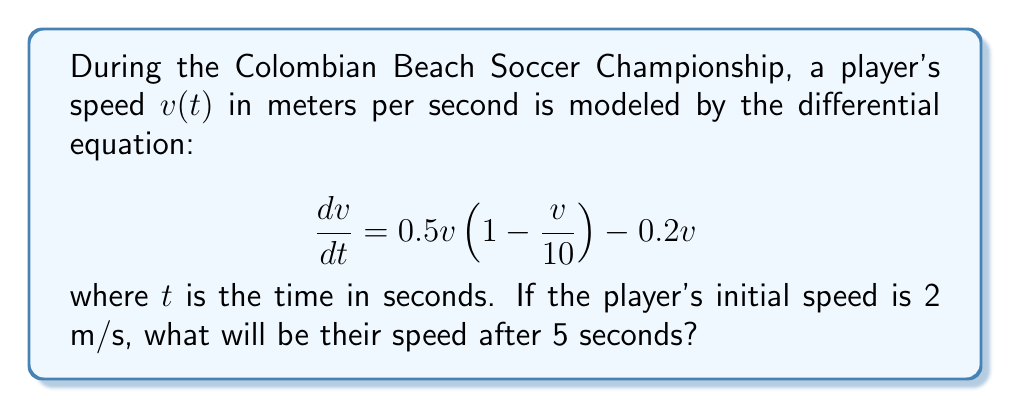What is the answer to this math problem? To solve this problem, we need to follow these steps:

1) First, let's simplify the differential equation:

   $$\frac{dv}{dt} = 0.5v(1 - \frac{v}{10}) - 0.2v = 0.5v - 0.05v^2 - 0.2v = 0.3v - 0.05v^2$$

2) This is a separable differential equation. Let's rearrange it:

   $$\frac{dv}{0.3v - 0.05v^2} = dt$$

3) Integrate both sides:

   $$\int \frac{dv}{0.3v - 0.05v^2} = \int dt$$

4) The left side can be integrated using partial fractions:

   $$\int \frac{dv}{0.3v - 0.05v^2} = -\frac{1}{3} \ln|3-0.5v| + C = t + C$$

5) Using the initial condition $v(0) = 2$, we can find the value of C:

   $$-\frac{1}{3} \ln|3-0.5(2)| + C = 0$$
   $$C = \frac{1}{3} \ln|2|$$

6) Now our solution is:

   $$-\frac{1}{3} \ln|3-0.5v| + \frac{1}{3} \ln|2| = t$$

7) Simplify:

   $$\ln|\frac{2}{3-0.5v}| = t$$

8) Exponentiate both sides:

   $$\frac{2}{3-0.5v} = e^t$$

9) Solve for v:

   $$v = 6 - \frac{4}{e^t}$$

10) Now we can find v(5) by substituting t=5:

    $$v(5) = 6 - \frac{4}{e^5} \approx 5.9733$$
Answer: The player's speed after 5 seconds will be approximately 5.97 m/s. 